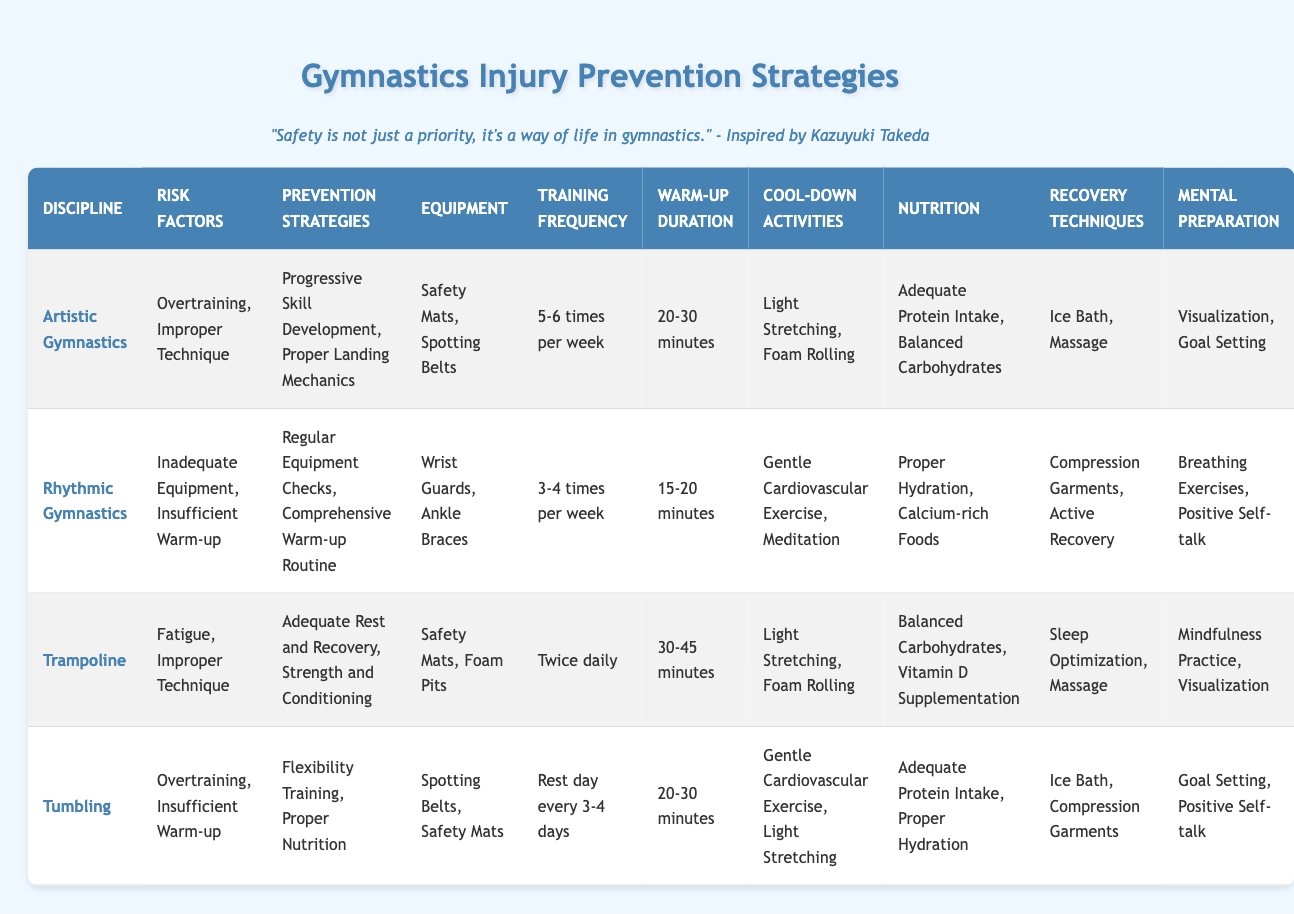What's the training frequency for Artistic Gymnastics? The table shows the training frequency specifically for Artistic Gymnastics as "5-6 times per week."
Answer: 5-6 times per week Which disciplines have "Improper Technique" as a risk factor? The table indicates that both "Artistic Gymnastics" and "Trampoline" list "Improper Technique" as a risk factor.
Answer: Artistic Gymnastics, Trampoline What are the recommended cool-down activities for Tumbling? Looking at the row for Tumbling, the recommended cool-down activities are "Gentle Cardiovascular Exercise" and "Light Stretching."
Answer: Gentle Cardiovascular Exercise, Light Stretching True or False: Flexibility Training is a prevention strategy in Rhythmic Gymnastics. The table does not list "Flexibility Training" under the prevention strategies for Rhythmic Gymnastics, so this statement is false.
Answer: False What is the difference between the warm-up duration for Rhythmic Gymnastics and Trampoline? Rhythmic Gymnastics has a warm-up duration of "15-20 minutes," while Trampoline has "30-45 minutes." The difference is therefore 15 minutes, taking the maximum of each range into account.
Answer: 15 minutes Which recovery technique is unique to Trampoline that is not listed for other disciplines? The table lists "Sleep Optimization" as a recovery technique specific to Trampoline that is not mentioned for other gymnastics disciplines.
Answer: Sleep Optimization How many injury risk factors are listed for Tumbling, and what are they? Tumbling has two risk factors listed: "Overtraining" and "Insufficient Warm-up." Therefore, the total is two risk factors.
Answer: 2: Overtraining, Insufficient Warm-up Is "Adequate Rest and Recovery" a prevention strategy used in Artistic Gymnastics? The table shows that "Adequate Rest and Recovery" is not listed as a prevention strategy for Artistic Gymnastics, making this statement false.
Answer: False What is the average warm-up duration recommended across all gymnastics disciplines? The warm-up durations listed are 15-20 minutes, 20-30 minutes, and 30-45 minutes. Converting these ranges to averages gives: (17.5 + 25 + 37.5) / 3 = 80 / 3 ≈ 26.67 minutes.
Answer: Approximately 26.67 minutes 